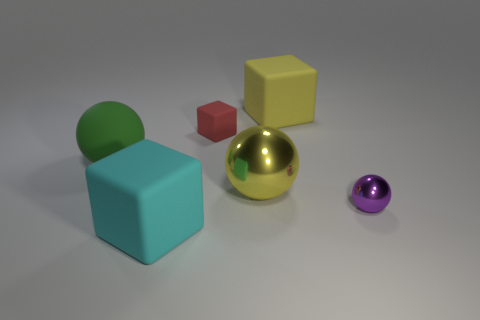Subtract all big yellow matte cubes. How many cubes are left? 2 Subtract 1 spheres. How many spheres are left? 2 Add 1 tiny gray metallic cubes. How many objects exist? 7 Subtract all brown blocks. Subtract all purple cylinders. How many blocks are left? 3 Subtract all big cyan matte cubes. Subtract all green spheres. How many objects are left? 4 Add 3 small rubber blocks. How many small rubber blocks are left? 4 Add 2 big yellow balls. How many big yellow balls exist? 3 Subtract 0 brown blocks. How many objects are left? 6 